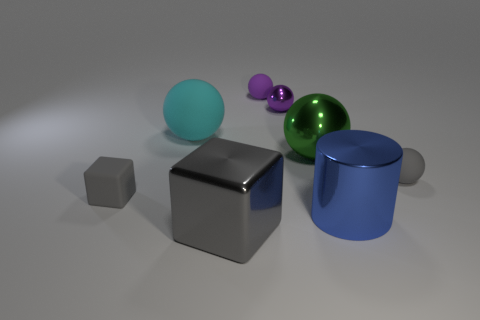Are there any gray matte things that have the same shape as the cyan object?
Your answer should be very brief. Yes. The big green metallic object is what shape?
Give a very brief answer. Sphere. There is a tiny gray object to the right of the big shiny object that is behind the gray rubber object to the left of the large cyan rubber object; what is its material?
Offer a very short reply. Rubber. Are there more large objects that are in front of the green metal sphere than large brown metallic cylinders?
Keep it short and to the point. Yes. What is the material of the cube that is the same size as the gray sphere?
Your answer should be compact. Rubber. Are there any cyan cubes that have the same size as the purple matte ball?
Your response must be concise. No. What is the size of the cube that is in front of the tiny gray rubber block?
Provide a short and direct response. Large. The purple rubber sphere is what size?
Your answer should be compact. Small. How many blocks are either small gray matte things or small purple rubber things?
Make the answer very short. 1. There is a gray cube that is made of the same material as the green sphere; what size is it?
Provide a short and direct response. Large. 